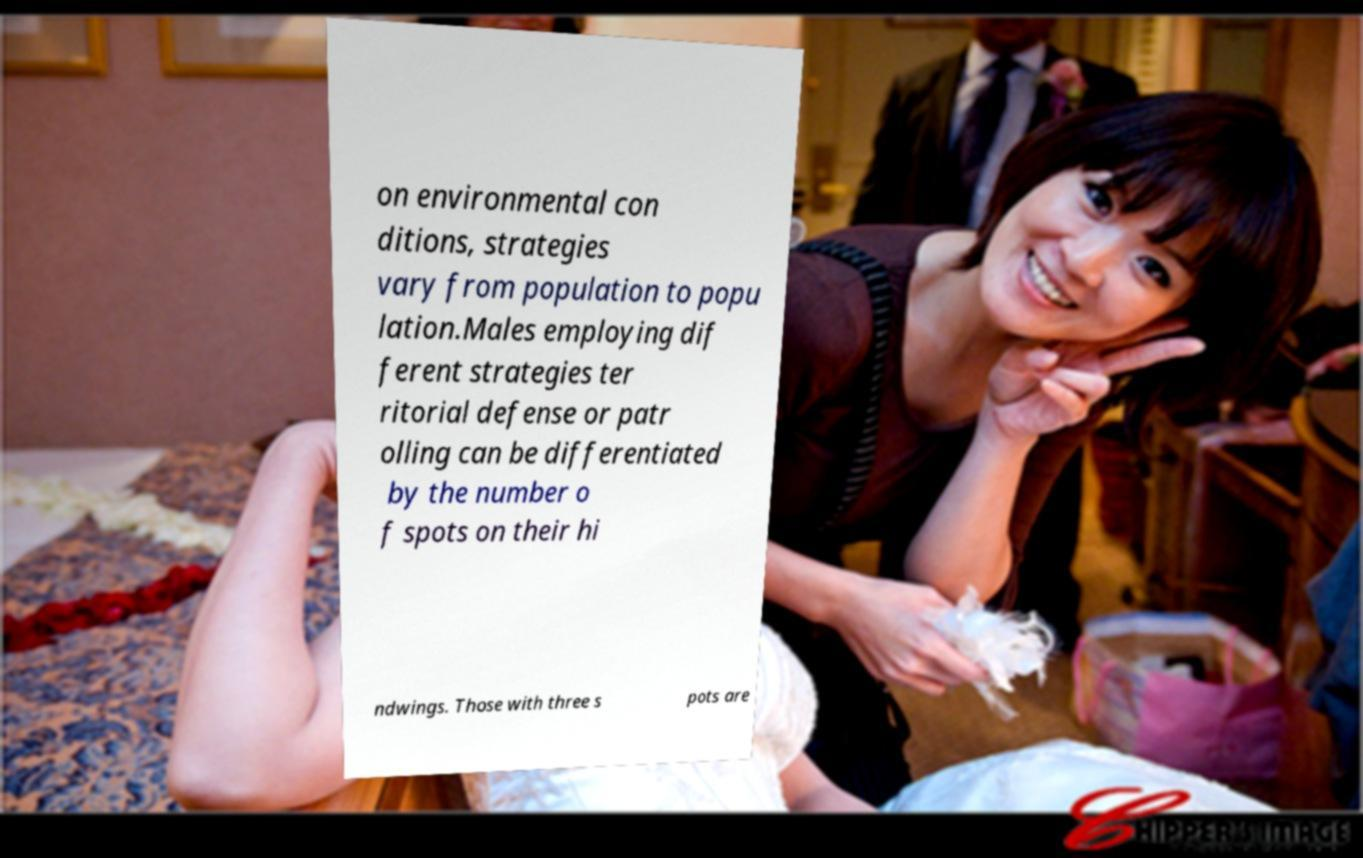Could you extract and type out the text from this image? on environmental con ditions, strategies vary from population to popu lation.Males employing dif ferent strategies ter ritorial defense or patr olling can be differentiated by the number o f spots on their hi ndwings. Those with three s pots are 